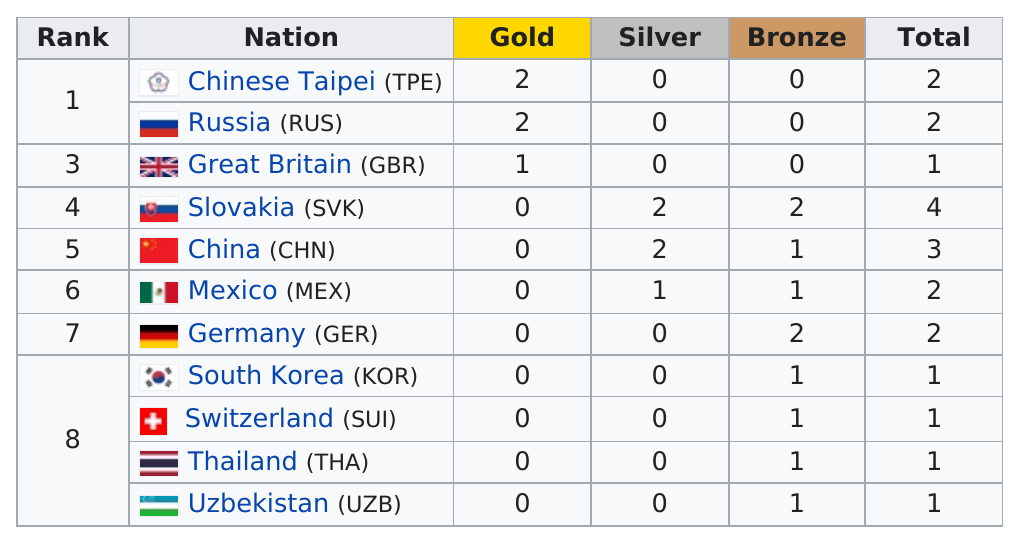Specify some key components in this picture. The difference in gold medals earned between Russia and Great Britain is 1. Russia earned a total of two gold medals. There are three countries that have at least one gold medal. The total number of medals won by all countries combined is 20. Slovakia earned the most non-gold medals out of all the countries. 